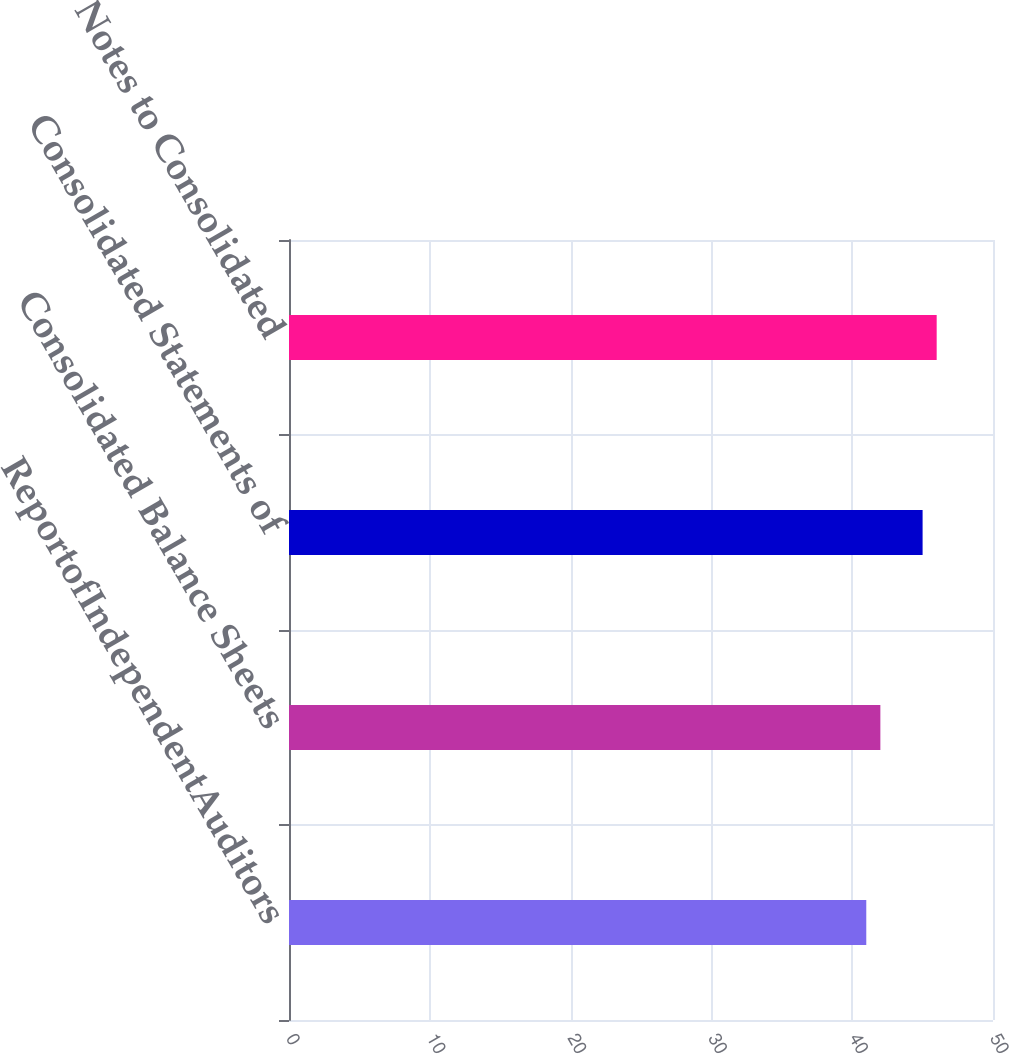Convert chart. <chart><loc_0><loc_0><loc_500><loc_500><bar_chart><fcel>ReportofIndependentAuditors<fcel>Consolidated Balance Sheets<fcel>Consolidated Statements of<fcel>Notes to Consolidated<nl><fcel>41<fcel>42<fcel>45<fcel>46<nl></chart> 